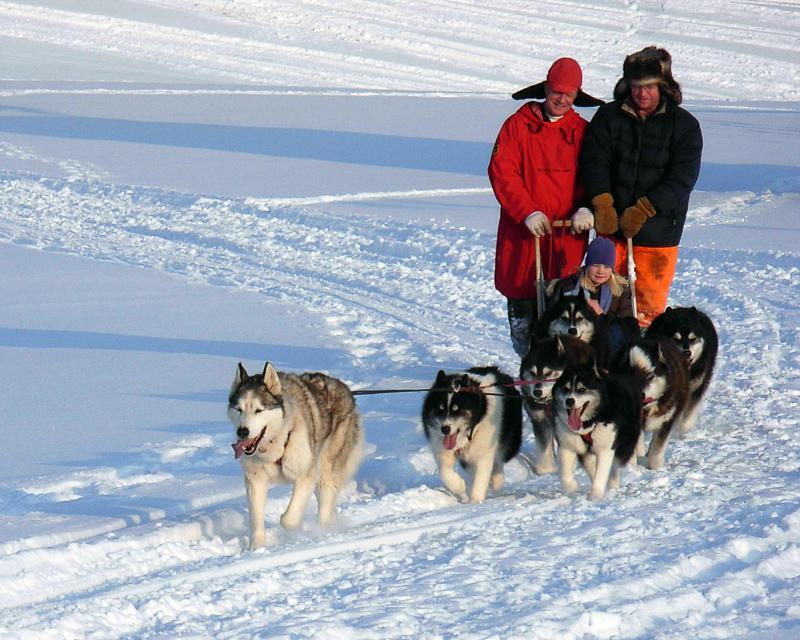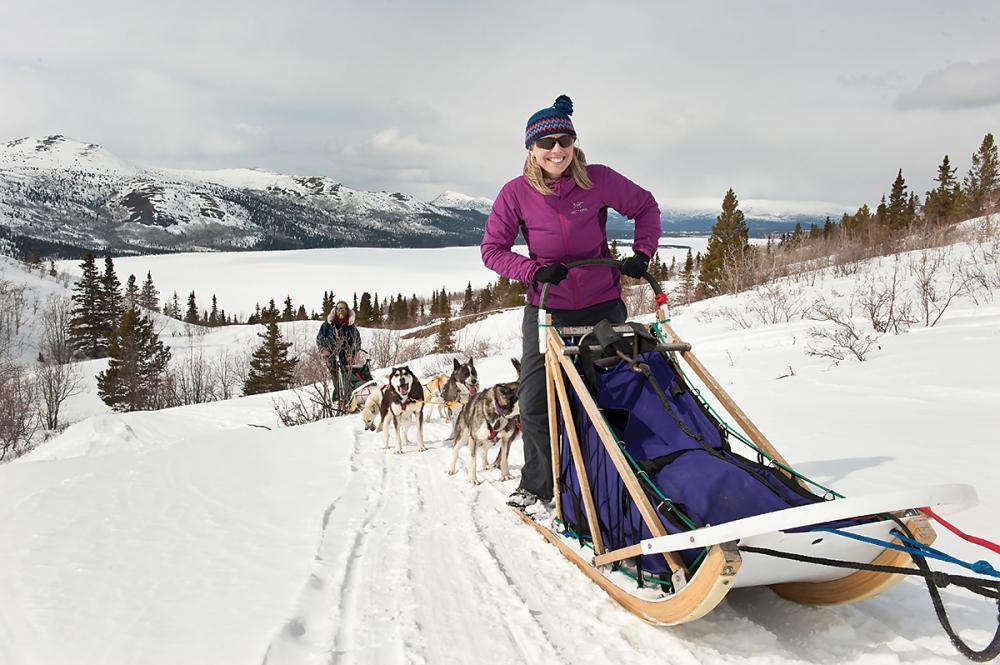The first image is the image on the left, the second image is the image on the right. Given the left and right images, does the statement "At least two dogs are in the foreground leading a dog sled in each image, and each image shows a dog team heading toward the camera." hold true? Answer yes or no. No. The first image is the image on the left, the second image is the image on the right. Assess this claim about the two images: "One image in the pair shows multiple dog sleds and the other shows a single dog sled with multiple people riding.". Correct or not? Answer yes or no. Yes. 